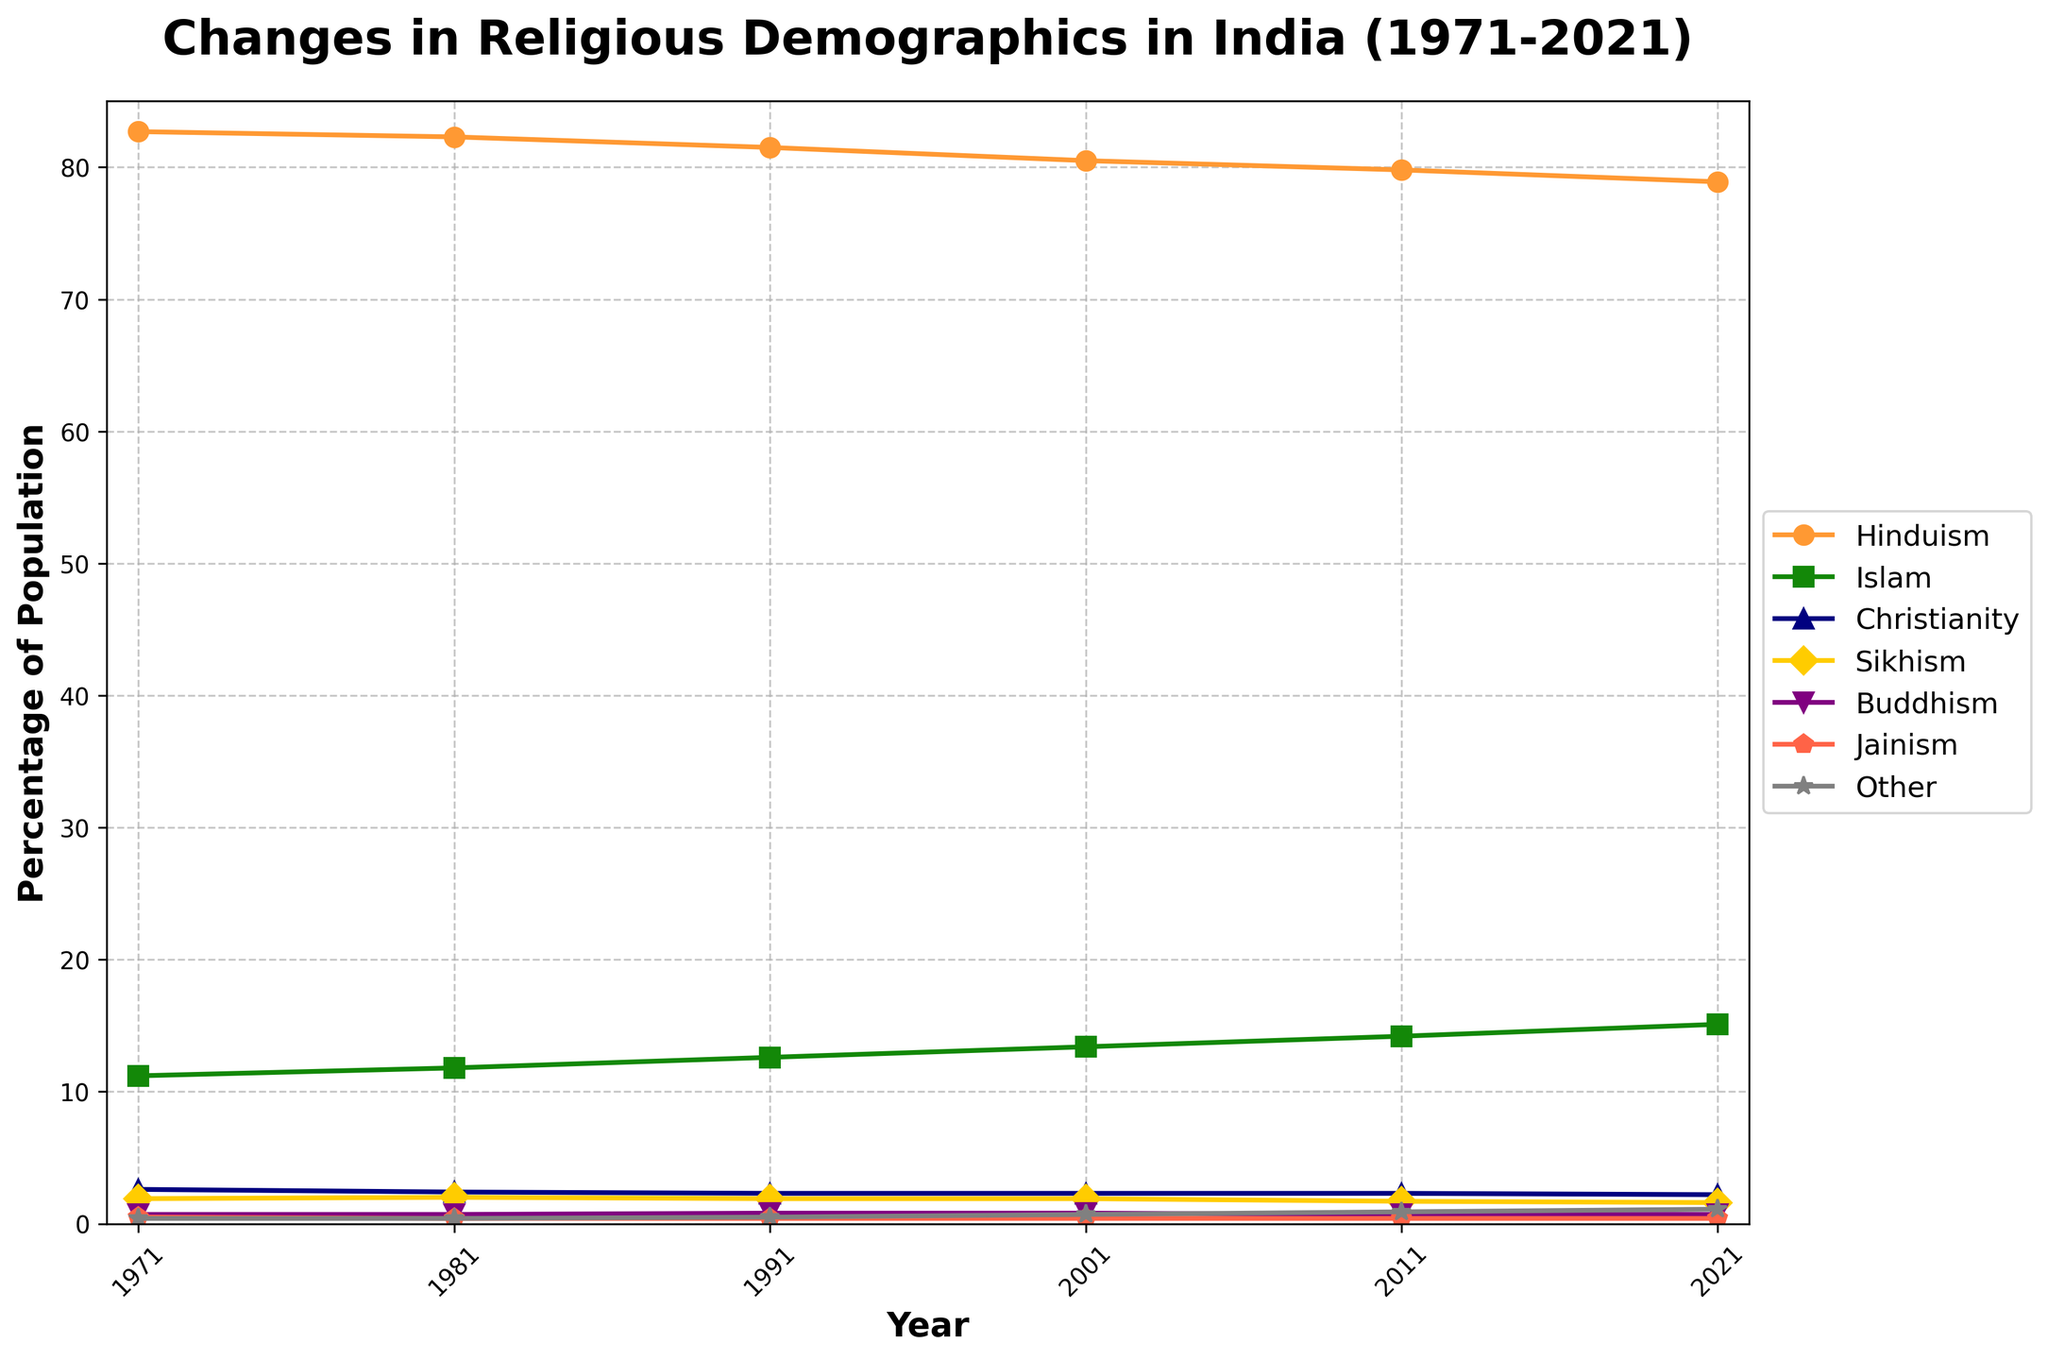What is the trend in the percentage of the Hinduism population over the 50 years? The line representing Hinduism shows a general downward trend from 82.7% in 1971 to 78.9% in 2021.
Answer: Downward trend Which religion saw the highest increase in percentage points from 1971 to 2021? By comparing the percentage points from the data for each religion from 1971 to 2021, Islam increased from 11.2% to 15.1%, which is the highest increase of 3.9 percentage points.
Answer: Islam By how many percentage points did the Sikhism population decrease between 1971 and 2021? To find the decrease, subtract the percentage in 2021 from the percentage in 1971 (1.9% - 1.6% = 0.3%).
Answer: 0.3% Did any religion show a relatively constant percentage over the years? By inspecting the lines for each religion, Jainism's percentage fluctuated only slightly from 0.5% in 1971 to 0.4% in 2021, indicating a relatively constant trend.
Answer: Jainism Between which two decades did Islam see the sharpest increase in percentage? By looking at the slope of the line representing Islam, the sharpest increase occurred between 1981 and 1991, increasing from 11.8% to 12.6%.
Answer: 1981 and 1991 How did the percentage of Christianity change over the 50 years? The line for Christianity stayed fairly stable, starting at 2.6% in 1971 and slightly decreasing to 2.2% in 2021.
Answer: Slightly decreased Comparing 1971 and 2021, which religion saw the largest decrease in percentage points? Hinduism saw the largest decrease from 82.7% in 1971 to 78.9% in 2021, a decrease of 3.8 percentage points.
Answer: Hinduism What is the combined percentage of Buddhism, Jainism, and "Other" in 2021? Add the percentages of Buddhism (0.7%), Jainism (0.4%), and Other (1.1%) to get the combined percentage (0.7% + 0.4% + 1.1% = 2.2%).
Answer: 2.2% Which religion had the smallest population percentage across all years? By comparing the lowest points in the figure, Jainism always had the smallest population percentage, remaining around 0.4% to 0.5% over the years.
Answer: Jainism Between which two consecutive decades did Hinduism show the largest percentage decrease? By inspecting the slope of the Hinduism line, the largest decrease occurred between 1991 and 2001, dropping from 81.5% to 80.5%.
Answer: 1991 and 2001 